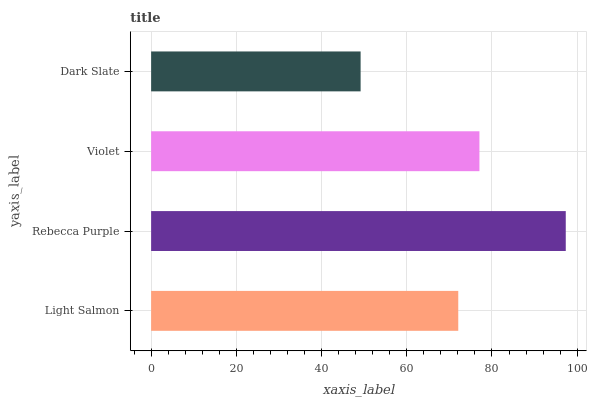Is Dark Slate the minimum?
Answer yes or no. Yes. Is Rebecca Purple the maximum?
Answer yes or no. Yes. Is Violet the minimum?
Answer yes or no. No. Is Violet the maximum?
Answer yes or no. No. Is Rebecca Purple greater than Violet?
Answer yes or no. Yes. Is Violet less than Rebecca Purple?
Answer yes or no. Yes. Is Violet greater than Rebecca Purple?
Answer yes or no. No. Is Rebecca Purple less than Violet?
Answer yes or no. No. Is Violet the high median?
Answer yes or no. Yes. Is Light Salmon the low median?
Answer yes or no. Yes. Is Rebecca Purple the high median?
Answer yes or no. No. Is Dark Slate the low median?
Answer yes or no. No. 